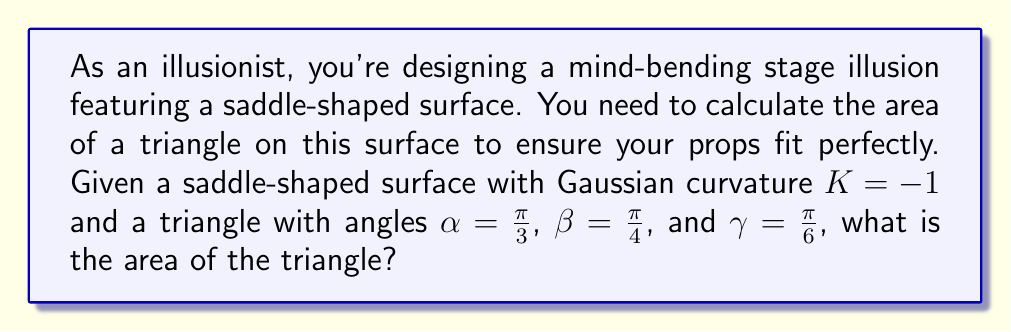Help me with this question. To solve this problem, we'll use the Gauss-Bonnet theorem for hyperbolic geometry. The steps are as follows:

1) The Gauss-Bonnet theorem states that for a triangle on a surface with constant Gaussian curvature $K$:

   $$A = \frac{\alpha + \beta + \gamma - \pi}{K}$$

   where $A$ is the area of the triangle, and $\alpha$, $\beta$, and $\gamma$ are the angles of the triangle.

2) We're given that $K = -1$ (negative because it's a saddle surface), and the angles are:
   
   $\alpha = \frac{\pi}{3}$, $\beta = \frac{\pi}{4}$, and $\gamma = \frac{\pi}{6}$

3) Let's sum the angles:

   $$\frac{\pi}{3} + \frac{\pi}{4} + \frac{\pi}{6} = \frac{4\pi}{12} + \frac{3\pi}{12} + \frac{2\pi}{12} = \frac{9\pi}{12} = \frac{3\pi}{4}$$

4) Now we can plug these values into the Gauss-Bonnet formula:

   $$A = \frac{(\frac{\pi}{3} + \frac{\pi}{4} + \frac{\pi}{6}) - \pi}{-1} = \frac{\frac{3\pi}{4} - \pi}{-1} = \frac{-\frac{\pi}{4}}{-1} = \frac{\pi}{4}$$

5) Therefore, the area of the triangle on this saddle-shaped surface is $\frac{\pi}{4}$ square units.
Answer: $\frac{\pi}{4}$ square units 